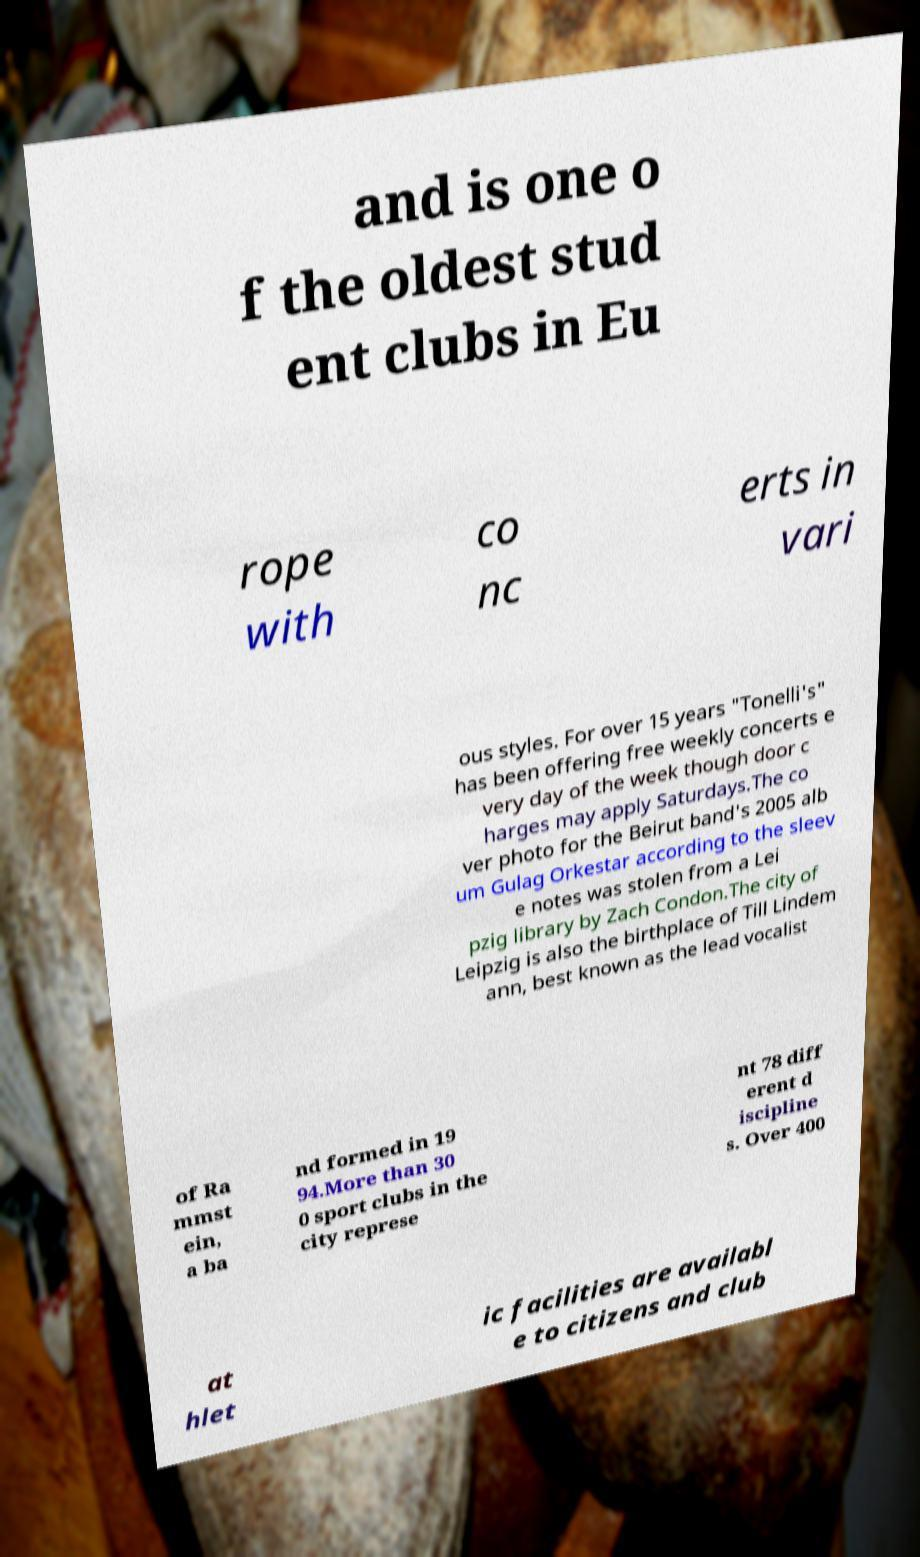What messages or text are displayed in this image? I need them in a readable, typed format. and is one o f the oldest stud ent clubs in Eu rope with co nc erts in vari ous styles. For over 15 years "Tonelli's" has been offering free weekly concerts e very day of the week though door c harges may apply Saturdays.The co ver photo for the Beirut band's 2005 alb um Gulag Orkestar according to the sleev e notes was stolen from a Lei pzig library by Zach Condon.The city of Leipzig is also the birthplace of Till Lindem ann, best known as the lead vocalist of Ra mmst ein, a ba nd formed in 19 94.More than 30 0 sport clubs in the city represe nt 78 diff erent d iscipline s. Over 400 at hlet ic facilities are availabl e to citizens and club 